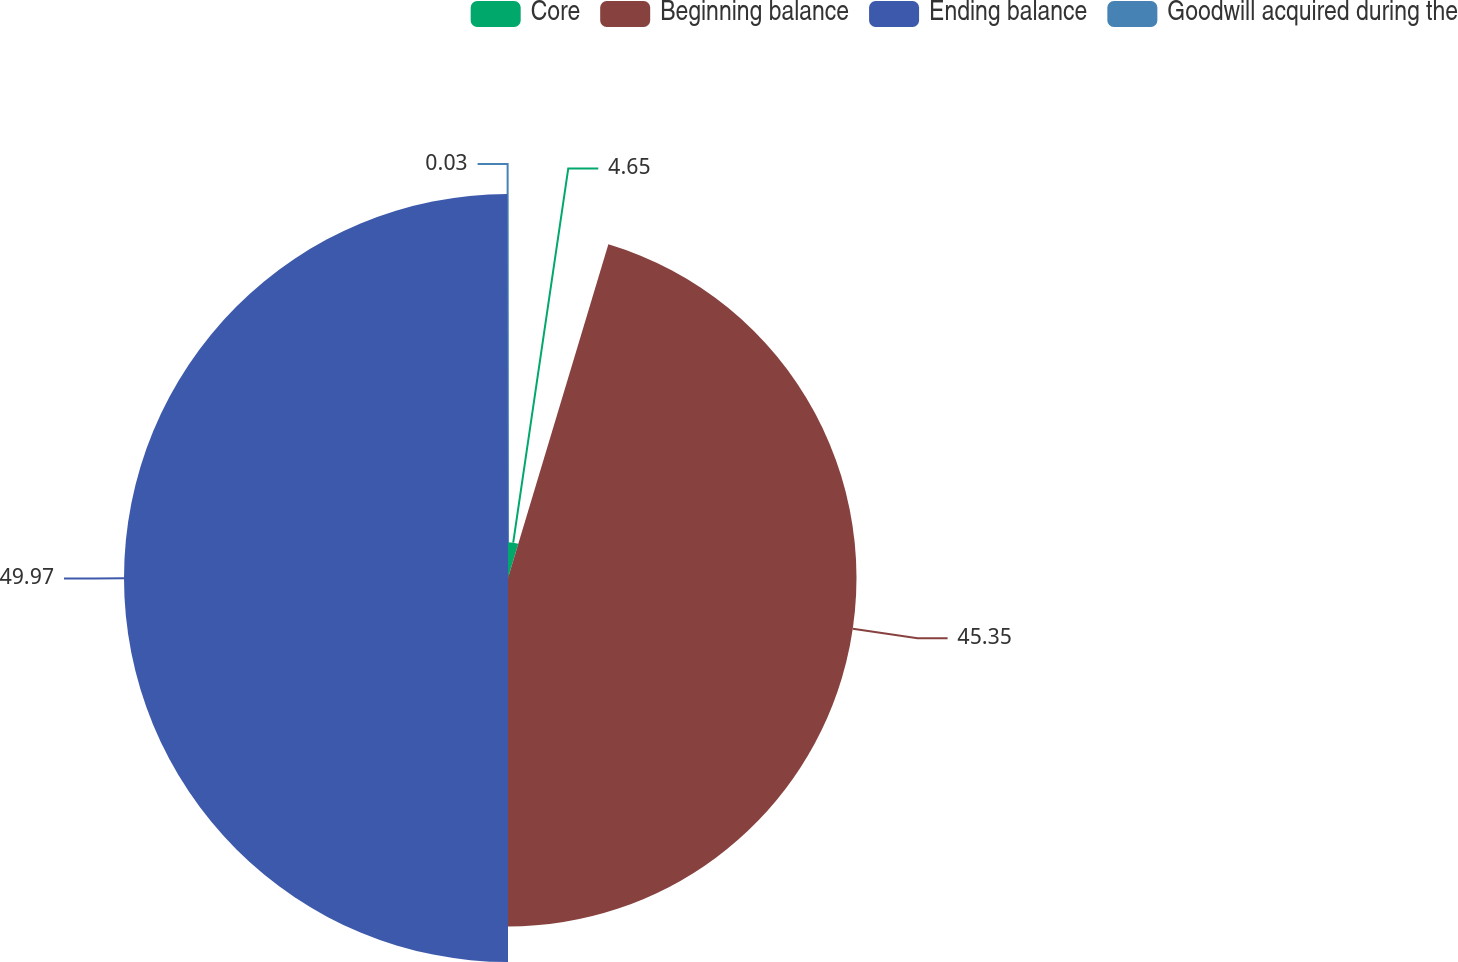<chart> <loc_0><loc_0><loc_500><loc_500><pie_chart><fcel>Core<fcel>Beginning balance<fcel>Ending balance<fcel>Goodwill acquired during the<nl><fcel>4.65%<fcel>45.35%<fcel>49.97%<fcel>0.03%<nl></chart> 